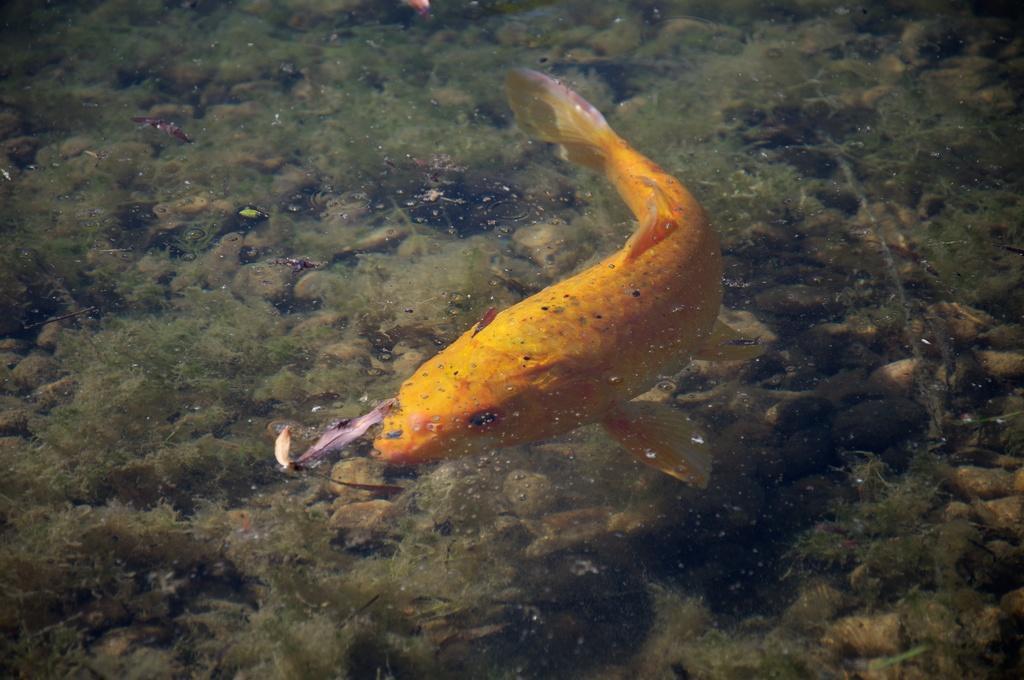Please provide a concise description of this image. In this image I can see a fish which is in yellow color in the water. Background I can see small plants in green color. 